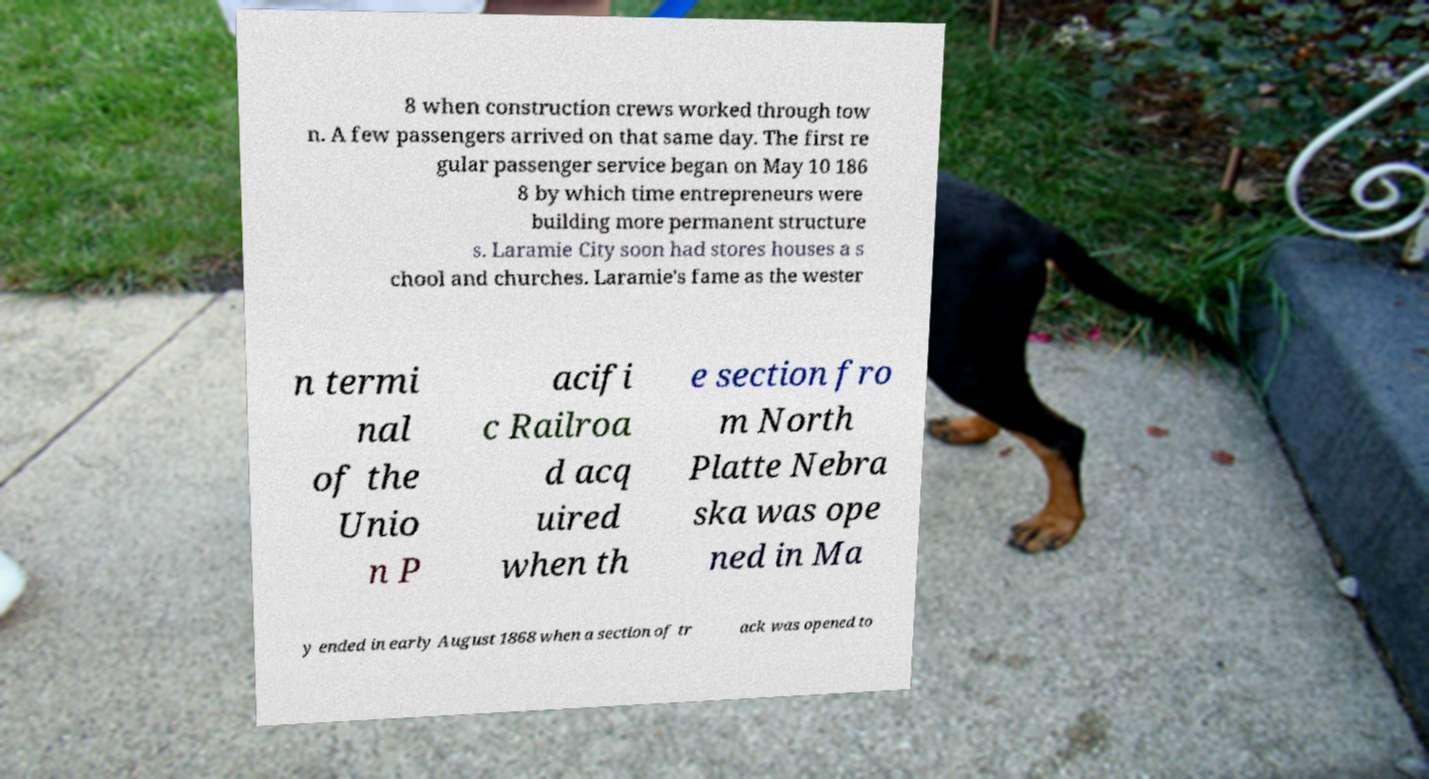There's text embedded in this image that I need extracted. Can you transcribe it verbatim? 8 when construction crews worked through tow n. A few passengers arrived on that same day. The first re gular passenger service began on May 10 186 8 by which time entrepreneurs were building more permanent structure s. Laramie City soon had stores houses a s chool and churches. Laramie's fame as the wester n termi nal of the Unio n P acifi c Railroa d acq uired when th e section fro m North Platte Nebra ska was ope ned in Ma y ended in early August 1868 when a section of tr ack was opened to 